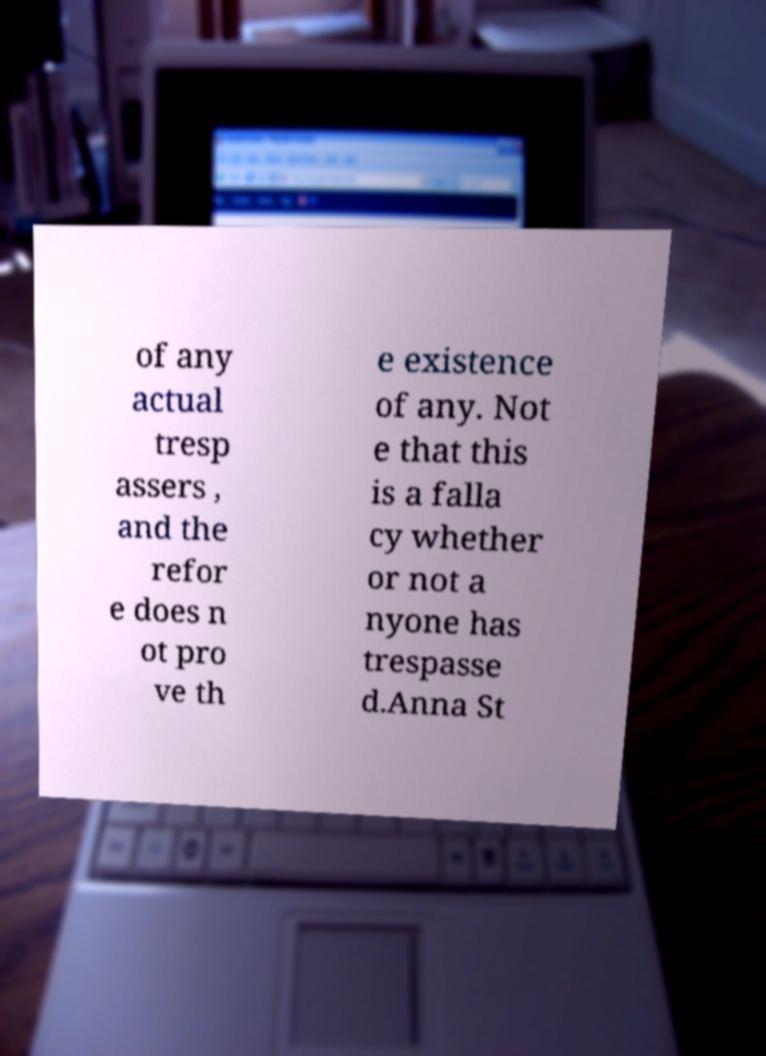I need the written content from this picture converted into text. Can you do that? of any actual tresp assers , and the refor e does n ot pro ve th e existence of any. Not e that this is a falla cy whether or not a nyone has trespasse d.Anna St 